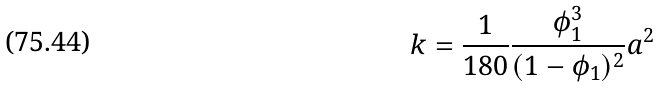<formula> <loc_0><loc_0><loc_500><loc_500>k = \frac { 1 } { 1 8 0 } \frac { \phi _ { 1 } ^ { 3 } } { ( 1 - \phi _ { 1 } ) ^ { 2 } } a ^ { 2 }</formula> 